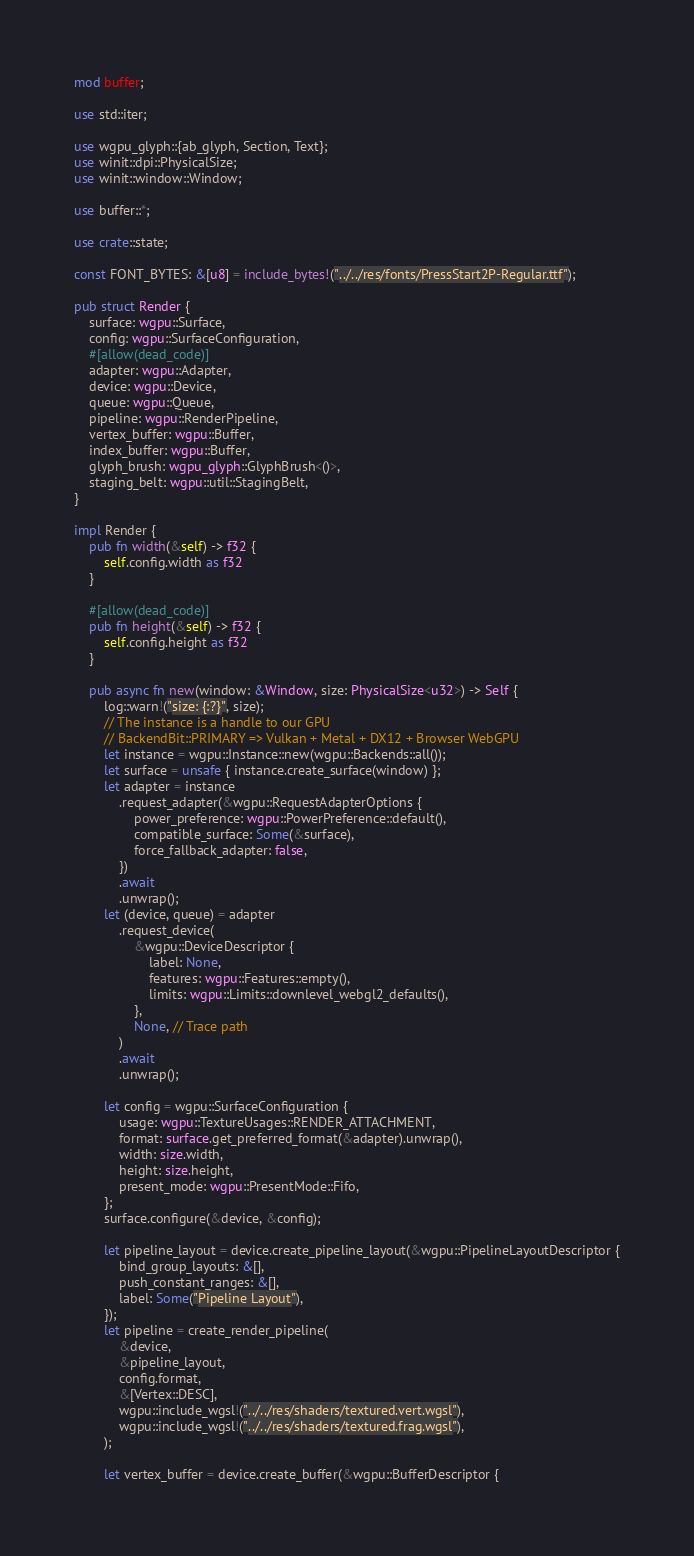<code> <loc_0><loc_0><loc_500><loc_500><_Rust_>mod buffer;

use std::iter;

use wgpu_glyph::{ab_glyph, Section, Text};
use winit::dpi::PhysicalSize;
use winit::window::Window;

use buffer::*;

use crate::state;

const FONT_BYTES: &[u8] = include_bytes!("../../res/fonts/PressStart2P-Regular.ttf");

pub struct Render {
    surface: wgpu::Surface,
    config: wgpu::SurfaceConfiguration,
    #[allow(dead_code)]
    adapter: wgpu::Adapter,
    device: wgpu::Device,
    queue: wgpu::Queue,
    pipeline: wgpu::RenderPipeline,
    vertex_buffer: wgpu::Buffer,
    index_buffer: wgpu::Buffer,
    glyph_brush: wgpu_glyph::GlyphBrush<()>,
    staging_belt: wgpu::util::StagingBelt,
}

impl Render {
    pub fn width(&self) -> f32 {
        self.config.width as f32
    }

    #[allow(dead_code)]
    pub fn height(&self) -> f32 {
        self.config.height as f32
    }

    pub async fn new(window: &Window, size: PhysicalSize<u32>) -> Self {
        log::warn!("size: {:?}", size);
        // The instance is a handle to our GPU
        // BackendBit::PRIMARY => Vulkan + Metal + DX12 + Browser WebGPU
        let instance = wgpu::Instance::new(wgpu::Backends::all());
        let surface = unsafe { instance.create_surface(window) };
        let adapter = instance
            .request_adapter(&wgpu::RequestAdapterOptions {
                power_preference: wgpu::PowerPreference::default(),
                compatible_surface: Some(&surface),
                force_fallback_adapter: false,
            })
            .await
            .unwrap();
        let (device, queue) = adapter
            .request_device(
                &wgpu::DeviceDescriptor {
                    label: None,
                    features: wgpu::Features::empty(),
                    limits: wgpu::Limits::downlevel_webgl2_defaults(),
                },
                None, // Trace path
            )
            .await
            .unwrap();

        let config = wgpu::SurfaceConfiguration {
            usage: wgpu::TextureUsages::RENDER_ATTACHMENT,
            format: surface.get_preferred_format(&adapter).unwrap(),
            width: size.width,
            height: size.height,
            present_mode: wgpu::PresentMode::Fifo,
        };
        surface.configure(&device, &config);

        let pipeline_layout = device.create_pipeline_layout(&wgpu::PipelineLayoutDescriptor {
            bind_group_layouts: &[],
            push_constant_ranges: &[],
            label: Some("Pipeline Layout"),
        });
        let pipeline = create_render_pipeline(
            &device,
            &pipeline_layout,
            config.format,
            &[Vertex::DESC],
            wgpu::include_wgsl!("../../res/shaders/textured.vert.wgsl"),
            wgpu::include_wgsl!("../../res/shaders/textured.frag.wgsl"),
        );

        let vertex_buffer = device.create_buffer(&wgpu::BufferDescriptor {</code> 